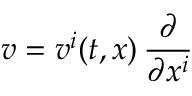Convert formula to latex. <formula><loc_0><loc_0><loc_500><loc_500>v = v ^ { i } ( t , x ) \, \frac { \partial } \partial x ^ { i } }</formula> 